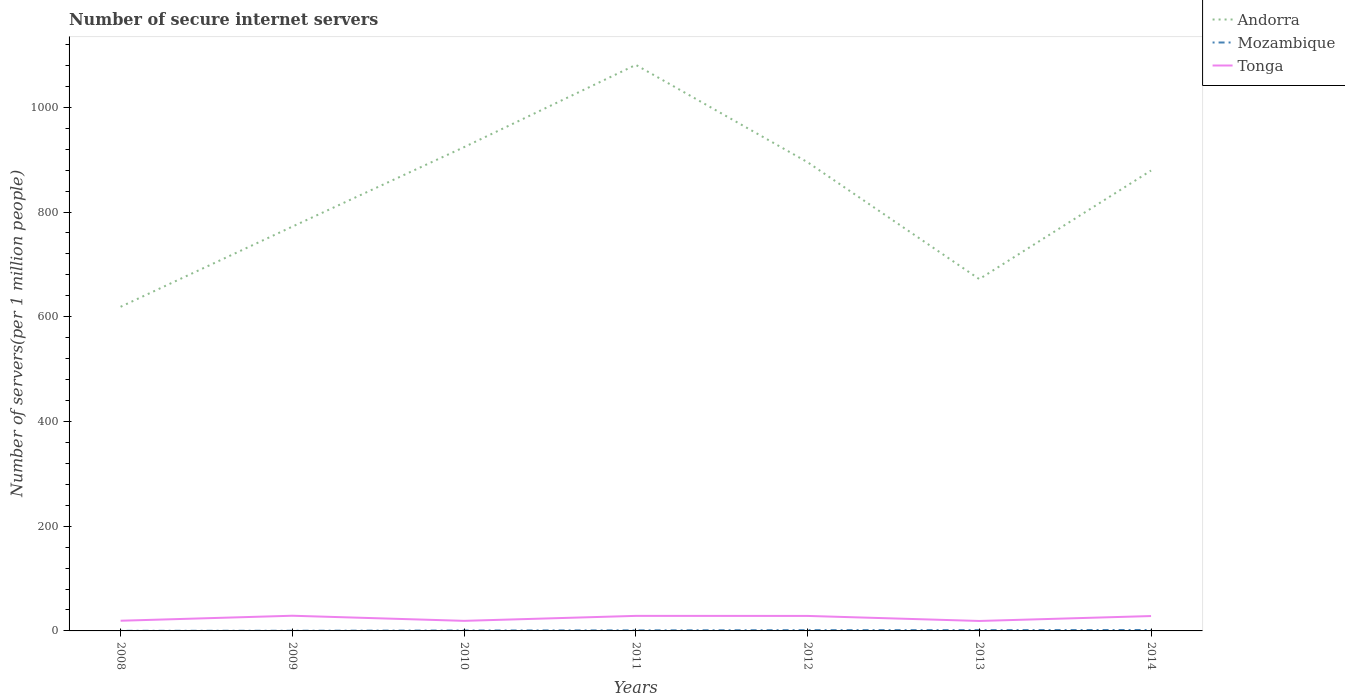Does the line corresponding to Mozambique intersect with the line corresponding to Tonga?
Keep it short and to the point. No. Is the number of lines equal to the number of legend labels?
Ensure brevity in your answer.  Yes. Across all years, what is the maximum number of secure internet servers in Andorra?
Provide a succinct answer. 619.04. In which year was the number of secure internet servers in Mozambique maximum?
Your response must be concise. 2008. What is the total number of secure internet servers in Andorra in the graph?
Offer a very short reply. 409.15. What is the difference between the highest and the second highest number of secure internet servers in Tonga?
Provide a succinct answer. 9.99. What is the difference between the highest and the lowest number of secure internet servers in Tonga?
Your answer should be compact. 4. How many lines are there?
Provide a succinct answer. 3. How many years are there in the graph?
Offer a very short reply. 7. What is the difference between two consecutive major ticks on the Y-axis?
Offer a terse response. 200. Are the values on the major ticks of Y-axis written in scientific E-notation?
Your answer should be very brief. No. Does the graph contain any zero values?
Keep it short and to the point. No. Where does the legend appear in the graph?
Provide a short and direct response. Top right. How are the legend labels stacked?
Your response must be concise. Vertical. What is the title of the graph?
Give a very brief answer. Number of secure internet servers. Does "Botswana" appear as one of the legend labels in the graph?
Your response must be concise. No. What is the label or title of the X-axis?
Provide a succinct answer. Years. What is the label or title of the Y-axis?
Make the answer very short. Number of servers(per 1 million people). What is the Number of servers(per 1 million people) in Andorra in 2008?
Provide a succinct answer. 619.04. What is the Number of servers(per 1 million people) of Mozambique in 2008?
Your answer should be very brief. 0.22. What is the Number of servers(per 1 million people) in Tonga in 2008?
Offer a very short reply. 19.45. What is the Number of servers(per 1 million people) of Andorra in 2009?
Your response must be concise. 772.16. What is the Number of servers(per 1 million people) of Mozambique in 2009?
Offer a very short reply. 0.34. What is the Number of servers(per 1 million people) in Tonga in 2009?
Offer a very short reply. 29.01. What is the Number of servers(per 1 million people) in Andorra in 2010?
Your response must be concise. 923.96. What is the Number of servers(per 1 million people) of Mozambique in 2010?
Give a very brief answer. 0.82. What is the Number of servers(per 1 million people) of Tonga in 2010?
Provide a succinct answer. 19.24. What is the Number of servers(per 1 million people) in Andorra in 2011?
Your answer should be compact. 1081.07. What is the Number of servers(per 1 million people) in Mozambique in 2011?
Ensure brevity in your answer.  1.08. What is the Number of servers(per 1 million people) of Tonga in 2011?
Give a very brief answer. 28.74. What is the Number of servers(per 1 million people) in Andorra in 2012?
Provide a succinct answer. 895.15. What is the Number of servers(per 1 million people) of Mozambique in 2012?
Provide a succinct answer. 1.48. What is the Number of servers(per 1 million people) in Tonga in 2012?
Keep it short and to the point. 28.63. What is the Number of servers(per 1 million people) in Andorra in 2013?
Offer a very short reply. 671.92. What is the Number of servers(per 1 million people) in Mozambique in 2013?
Provide a short and direct response. 1.55. What is the Number of servers(per 1 million people) in Tonga in 2013?
Keep it short and to the point. 19.02. What is the Number of servers(per 1 million people) in Andorra in 2014?
Keep it short and to the point. 879.29. What is the Number of servers(per 1 million people) in Mozambique in 2014?
Make the answer very short. 1.76. What is the Number of servers(per 1 million people) in Tonga in 2014?
Make the answer very short. 28.41. Across all years, what is the maximum Number of servers(per 1 million people) of Andorra?
Provide a short and direct response. 1081.07. Across all years, what is the maximum Number of servers(per 1 million people) of Mozambique?
Give a very brief answer. 1.76. Across all years, what is the maximum Number of servers(per 1 million people) of Tonga?
Make the answer very short. 29.01. Across all years, what is the minimum Number of servers(per 1 million people) of Andorra?
Give a very brief answer. 619.04. Across all years, what is the minimum Number of servers(per 1 million people) in Mozambique?
Offer a very short reply. 0.22. Across all years, what is the minimum Number of servers(per 1 million people) of Tonga?
Give a very brief answer. 19.02. What is the total Number of servers(per 1 million people) in Andorra in the graph?
Make the answer very short. 5842.6. What is the total Number of servers(per 1 million people) of Mozambique in the graph?
Offer a terse response. 7.25. What is the total Number of servers(per 1 million people) in Tonga in the graph?
Your answer should be very brief. 172.51. What is the difference between the Number of servers(per 1 million people) in Andorra in 2008 and that in 2009?
Offer a very short reply. -153.12. What is the difference between the Number of servers(per 1 million people) in Mozambique in 2008 and that in 2009?
Keep it short and to the point. -0.12. What is the difference between the Number of servers(per 1 million people) of Tonga in 2008 and that in 2009?
Your answer should be very brief. -9.56. What is the difference between the Number of servers(per 1 million people) in Andorra in 2008 and that in 2010?
Provide a short and direct response. -304.92. What is the difference between the Number of servers(per 1 million people) of Mozambique in 2008 and that in 2010?
Offer a terse response. -0.6. What is the difference between the Number of servers(per 1 million people) in Tonga in 2008 and that in 2010?
Give a very brief answer. 0.21. What is the difference between the Number of servers(per 1 million people) in Andorra in 2008 and that in 2011?
Your answer should be compact. -462.02. What is the difference between the Number of servers(per 1 million people) in Mozambique in 2008 and that in 2011?
Offer a terse response. -0.86. What is the difference between the Number of servers(per 1 million people) in Tonga in 2008 and that in 2011?
Offer a very short reply. -9.29. What is the difference between the Number of servers(per 1 million people) in Andorra in 2008 and that in 2012?
Make the answer very short. -276.11. What is the difference between the Number of servers(per 1 million people) in Mozambique in 2008 and that in 2012?
Give a very brief answer. -1.26. What is the difference between the Number of servers(per 1 million people) of Tonga in 2008 and that in 2012?
Ensure brevity in your answer.  -9.18. What is the difference between the Number of servers(per 1 million people) of Andorra in 2008 and that in 2013?
Your answer should be very brief. -52.88. What is the difference between the Number of servers(per 1 million people) of Mozambique in 2008 and that in 2013?
Offer a very short reply. -1.33. What is the difference between the Number of servers(per 1 million people) of Tonga in 2008 and that in 2013?
Your answer should be compact. 0.43. What is the difference between the Number of servers(per 1 million people) of Andorra in 2008 and that in 2014?
Keep it short and to the point. -260.25. What is the difference between the Number of servers(per 1 million people) in Mozambique in 2008 and that in 2014?
Keep it short and to the point. -1.55. What is the difference between the Number of servers(per 1 million people) of Tonga in 2008 and that in 2014?
Provide a short and direct response. -8.96. What is the difference between the Number of servers(per 1 million people) in Andorra in 2009 and that in 2010?
Offer a very short reply. -151.8. What is the difference between the Number of servers(per 1 million people) in Mozambique in 2009 and that in 2010?
Give a very brief answer. -0.48. What is the difference between the Number of servers(per 1 million people) of Tonga in 2009 and that in 2010?
Give a very brief answer. 9.77. What is the difference between the Number of servers(per 1 million people) of Andorra in 2009 and that in 2011?
Your answer should be very brief. -308.9. What is the difference between the Number of servers(per 1 million people) of Mozambique in 2009 and that in 2011?
Offer a terse response. -0.74. What is the difference between the Number of servers(per 1 million people) in Tonga in 2009 and that in 2011?
Make the answer very short. 0.27. What is the difference between the Number of servers(per 1 million people) in Andorra in 2009 and that in 2012?
Ensure brevity in your answer.  -122.99. What is the difference between the Number of servers(per 1 million people) in Mozambique in 2009 and that in 2012?
Give a very brief answer. -1.14. What is the difference between the Number of servers(per 1 million people) of Tonga in 2009 and that in 2012?
Ensure brevity in your answer.  0.37. What is the difference between the Number of servers(per 1 million people) of Andorra in 2009 and that in 2013?
Give a very brief answer. 100.25. What is the difference between the Number of servers(per 1 million people) of Mozambique in 2009 and that in 2013?
Your response must be concise. -1.21. What is the difference between the Number of servers(per 1 million people) in Tonga in 2009 and that in 2013?
Provide a succinct answer. 9.99. What is the difference between the Number of servers(per 1 million people) of Andorra in 2009 and that in 2014?
Your response must be concise. -107.13. What is the difference between the Number of servers(per 1 million people) of Mozambique in 2009 and that in 2014?
Offer a terse response. -1.43. What is the difference between the Number of servers(per 1 million people) of Tonga in 2009 and that in 2014?
Provide a succinct answer. 0.6. What is the difference between the Number of servers(per 1 million people) in Andorra in 2010 and that in 2011?
Your answer should be very brief. -157.11. What is the difference between the Number of servers(per 1 million people) in Mozambique in 2010 and that in 2011?
Keep it short and to the point. -0.26. What is the difference between the Number of servers(per 1 million people) of Tonga in 2010 and that in 2011?
Your answer should be very brief. -9.5. What is the difference between the Number of servers(per 1 million people) in Andorra in 2010 and that in 2012?
Provide a short and direct response. 28.81. What is the difference between the Number of servers(per 1 million people) in Mozambique in 2010 and that in 2012?
Offer a terse response. -0.65. What is the difference between the Number of servers(per 1 million people) of Tonga in 2010 and that in 2012?
Keep it short and to the point. -9.39. What is the difference between the Number of servers(per 1 million people) of Andorra in 2010 and that in 2013?
Give a very brief answer. 252.04. What is the difference between the Number of servers(per 1 million people) in Mozambique in 2010 and that in 2013?
Keep it short and to the point. -0.73. What is the difference between the Number of servers(per 1 million people) in Tonga in 2010 and that in 2013?
Make the answer very short. 0.22. What is the difference between the Number of servers(per 1 million people) in Andorra in 2010 and that in 2014?
Your answer should be very brief. 44.67. What is the difference between the Number of servers(per 1 million people) in Mozambique in 2010 and that in 2014?
Offer a very short reply. -0.94. What is the difference between the Number of servers(per 1 million people) in Tonga in 2010 and that in 2014?
Your response must be concise. -9.17. What is the difference between the Number of servers(per 1 million people) of Andorra in 2011 and that in 2012?
Your answer should be compact. 185.91. What is the difference between the Number of servers(per 1 million people) of Mozambique in 2011 and that in 2012?
Give a very brief answer. -0.4. What is the difference between the Number of servers(per 1 million people) of Tonga in 2011 and that in 2012?
Give a very brief answer. 0.1. What is the difference between the Number of servers(per 1 million people) of Andorra in 2011 and that in 2013?
Offer a very short reply. 409.15. What is the difference between the Number of servers(per 1 million people) of Mozambique in 2011 and that in 2013?
Your answer should be very brief. -0.47. What is the difference between the Number of servers(per 1 million people) in Tonga in 2011 and that in 2013?
Ensure brevity in your answer.  9.72. What is the difference between the Number of servers(per 1 million people) in Andorra in 2011 and that in 2014?
Give a very brief answer. 201.78. What is the difference between the Number of servers(per 1 million people) in Mozambique in 2011 and that in 2014?
Ensure brevity in your answer.  -0.68. What is the difference between the Number of servers(per 1 million people) of Tonga in 2011 and that in 2014?
Keep it short and to the point. 0.33. What is the difference between the Number of servers(per 1 million people) in Andorra in 2012 and that in 2013?
Offer a terse response. 223.23. What is the difference between the Number of servers(per 1 million people) of Mozambique in 2012 and that in 2013?
Ensure brevity in your answer.  -0.07. What is the difference between the Number of servers(per 1 million people) of Tonga in 2012 and that in 2013?
Ensure brevity in your answer.  9.61. What is the difference between the Number of servers(per 1 million people) in Andorra in 2012 and that in 2014?
Keep it short and to the point. 15.86. What is the difference between the Number of servers(per 1 million people) in Mozambique in 2012 and that in 2014?
Your response must be concise. -0.29. What is the difference between the Number of servers(per 1 million people) in Tonga in 2012 and that in 2014?
Offer a terse response. 0.22. What is the difference between the Number of servers(per 1 million people) of Andorra in 2013 and that in 2014?
Keep it short and to the point. -207.37. What is the difference between the Number of servers(per 1 million people) of Mozambique in 2013 and that in 2014?
Ensure brevity in your answer.  -0.21. What is the difference between the Number of servers(per 1 million people) in Tonga in 2013 and that in 2014?
Offer a terse response. -9.39. What is the difference between the Number of servers(per 1 million people) of Andorra in 2008 and the Number of servers(per 1 million people) of Mozambique in 2009?
Provide a succinct answer. 618.7. What is the difference between the Number of servers(per 1 million people) in Andorra in 2008 and the Number of servers(per 1 million people) in Tonga in 2009?
Your response must be concise. 590.03. What is the difference between the Number of servers(per 1 million people) in Mozambique in 2008 and the Number of servers(per 1 million people) in Tonga in 2009?
Provide a succinct answer. -28.79. What is the difference between the Number of servers(per 1 million people) in Andorra in 2008 and the Number of servers(per 1 million people) in Mozambique in 2010?
Keep it short and to the point. 618.22. What is the difference between the Number of servers(per 1 million people) of Andorra in 2008 and the Number of servers(per 1 million people) of Tonga in 2010?
Offer a terse response. 599.8. What is the difference between the Number of servers(per 1 million people) of Mozambique in 2008 and the Number of servers(per 1 million people) of Tonga in 2010?
Keep it short and to the point. -19.02. What is the difference between the Number of servers(per 1 million people) of Andorra in 2008 and the Number of servers(per 1 million people) of Mozambique in 2011?
Provide a succinct answer. 617.96. What is the difference between the Number of servers(per 1 million people) in Andorra in 2008 and the Number of servers(per 1 million people) in Tonga in 2011?
Offer a very short reply. 590.31. What is the difference between the Number of servers(per 1 million people) of Mozambique in 2008 and the Number of servers(per 1 million people) of Tonga in 2011?
Your answer should be very brief. -28.52. What is the difference between the Number of servers(per 1 million people) of Andorra in 2008 and the Number of servers(per 1 million people) of Mozambique in 2012?
Your response must be concise. 617.57. What is the difference between the Number of servers(per 1 million people) in Andorra in 2008 and the Number of servers(per 1 million people) in Tonga in 2012?
Provide a short and direct response. 590.41. What is the difference between the Number of servers(per 1 million people) in Mozambique in 2008 and the Number of servers(per 1 million people) in Tonga in 2012?
Ensure brevity in your answer.  -28.42. What is the difference between the Number of servers(per 1 million people) of Andorra in 2008 and the Number of servers(per 1 million people) of Mozambique in 2013?
Make the answer very short. 617.49. What is the difference between the Number of servers(per 1 million people) in Andorra in 2008 and the Number of servers(per 1 million people) in Tonga in 2013?
Ensure brevity in your answer.  600.02. What is the difference between the Number of servers(per 1 million people) in Mozambique in 2008 and the Number of servers(per 1 million people) in Tonga in 2013?
Provide a short and direct response. -18.8. What is the difference between the Number of servers(per 1 million people) in Andorra in 2008 and the Number of servers(per 1 million people) in Mozambique in 2014?
Your answer should be very brief. 617.28. What is the difference between the Number of servers(per 1 million people) of Andorra in 2008 and the Number of servers(per 1 million people) of Tonga in 2014?
Ensure brevity in your answer.  590.63. What is the difference between the Number of servers(per 1 million people) in Mozambique in 2008 and the Number of servers(per 1 million people) in Tonga in 2014?
Ensure brevity in your answer.  -28.2. What is the difference between the Number of servers(per 1 million people) in Andorra in 2009 and the Number of servers(per 1 million people) in Mozambique in 2010?
Keep it short and to the point. 771.34. What is the difference between the Number of servers(per 1 million people) of Andorra in 2009 and the Number of servers(per 1 million people) of Tonga in 2010?
Keep it short and to the point. 752.92. What is the difference between the Number of servers(per 1 million people) of Mozambique in 2009 and the Number of servers(per 1 million people) of Tonga in 2010?
Provide a short and direct response. -18.9. What is the difference between the Number of servers(per 1 million people) of Andorra in 2009 and the Number of servers(per 1 million people) of Mozambique in 2011?
Ensure brevity in your answer.  771.09. What is the difference between the Number of servers(per 1 million people) of Andorra in 2009 and the Number of servers(per 1 million people) of Tonga in 2011?
Your answer should be compact. 743.43. What is the difference between the Number of servers(per 1 million people) in Mozambique in 2009 and the Number of servers(per 1 million people) in Tonga in 2011?
Keep it short and to the point. -28.4. What is the difference between the Number of servers(per 1 million people) of Andorra in 2009 and the Number of servers(per 1 million people) of Mozambique in 2012?
Give a very brief answer. 770.69. What is the difference between the Number of servers(per 1 million people) of Andorra in 2009 and the Number of servers(per 1 million people) of Tonga in 2012?
Offer a very short reply. 743.53. What is the difference between the Number of servers(per 1 million people) of Mozambique in 2009 and the Number of servers(per 1 million people) of Tonga in 2012?
Your response must be concise. -28.3. What is the difference between the Number of servers(per 1 million people) of Andorra in 2009 and the Number of servers(per 1 million people) of Mozambique in 2013?
Keep it short and to the point. 770.62. What is the difference between the Number of servers(per 1 million people) of Andorra in 2009 and the Number of servers(per 1 million people) of Tonga in 2013?
Your answer should be compact. 753.14. What is the difference between the Number of servers(per 1 million people) in Mozambique in 2009 and the Number of servers(per 1 million people) in Tonga in 2013?
Ensure brevity in your answer.  -18.68. What is the difference between the Number of servers(per 1 million people) in Andorra in 2009 and the Number of servers(per 1 million people) in Mozambique in 2014?
Provide a succinct answer. 770.4. What is the difference between the Number of servers(per 1 million people) in Andorra in 2009 and the Number of servers(per 1 million people) in Tonga in 2014?
Your answer should be very brief. 743.75. What is the difference between the Number of servers(per 1 million people) in Mozambique in 2009 and the Number of servers(per 1 million people) in Tonga in 2014?
Provide a succinct answer. -28.07. What is the difference between the Number of servers(per 1 million people) of Andorra in 2010 and the Number of servers(per 1 million people) of Mozambique in 2011?
Provide a succinct answer. 922.88. What is the difference between the Number of servers(per 1 million people) of Andorra in 2010 and the Number of servers(per 1 million people) of Tonga in 2011?
Your answer should be compact. 895.22. What is the difference between the Number of servers(per 1 million people) of Mozambique in 2010 and the Number of servers(per 1 million people) of Tonga in 2011?
Your answer should be very brief. -27.92. What is the difference between the Number of servers(per 1 million people) of Andorra in 2010 and the Number of servers(per 1 million people) of Mozambique in 2012?
Make the answer very short. 922.49. What is the difference between the Number of servers(per 1 million people) in Andorra in 2010 and the Number of servers(per 1 million people) in Tonga in 2012?
Provide a succinct answer. 895.33. What is the difference between the Number of servers(per 1 million people) of Mozambique in 2010 and the Number of servers(per 1 million people) of Tonga in 2012?
Offer a very short reply. -27.81. What is the difference between the Number of servers(per 1 million people) of Andorra in 2010 and the Number of servers(per 1 million people) of Mozambique in 2013?
Provide a short and direct response. 922.41. What is the difference between the Number of servers(per 1 million people) of Andorra in 2010 and the Number of servers(per 1 million people) of Tonga in 2013?
Make the answer very short. 904.94. What is the difference between the Number of servers(per 1 million people) of Mozambique in 2010 and the Number of servers(per 1 million people) of Tonga in 2013?
Provide a succinct answer. -18.2. What is the difference between the Number of servers(per 1 million people) of Andorra in 2010 and the Number of servers(per 1 million people) of Mozambique in 2014?
Ensure brevity in your answer.  922.2. What is the difference between the Number of servers(per 1 million people) in Andorra in 2010 and the Number of servers(per 1 million people) in Tonga in 2014?
Your answer should be compact. 895.55. What is the difference between the Number of servers(per 1 million people) in Mozambique in 2010 and the Number of servers(per 1 million people) in Tonga in 2014?
Provide a succinct answer. -27.59. What is the difference between the Number of servers(per 1 million people) of Andorra in 2011 and the Number of servers(per 1 million people) of Mozambique in 2012?
Your answer should be compact. 1079.59. What is the difference between the Number of servers(per 1 million people) of Andorra in 2011 and the Number of servers(per 1 million people) of Tonga in 2012?
Provide a short and direct response. 1052.43. What is the difference between the Number of servers(per 1 million people) of Mozambique in 2011 and the Number of servers(per 1 million people) of Tonga in 2012?
Your answer should be very brief. -27.56. What is the difference between the Number of servers(per 1 million people) of Andorra in 2011 and the Number of servers(per 1 million people) of Mozambique in 2013?
Ensure brevity in your answer.  1079.52. What is the difference between the Number of servers(per 1 million people) of Andorra in 2011 and the Number of servers(per 1 million people) of Tonga in 2013?
Make the answer very short. 1062.05. What is the difference between the Number of servers(per 1 million people) in Mozambique in 2011 and the Number of servers(per 1 million people) in Tonga in 2013?
Keep it short and to the point. -17.94. What is the difference between the Number of servers(per 1 million people) in Andorra in 2011 and the Number of servers(per 1 million people) in Mozambique in 2014?
Keep it short and to the point. 1079.3. What is the difference between the Number of servers(per 1 million people) of Andorra in 2011 and the Number of servers(per 1 million people) of Tonga in 2014?
Ensure brevity in your answer.  1052.66. What is the difference between the Number of servers(per 1 million people) in Mozambique in 2011 and the Number of servers(per 1 million people) in Tonga in 2014?
Keep it short and to the point. -27.33. What is the difference between the Number of servers(per 1 million people) in Andorra in 2012 and the Number of servers(per 1 million people) in Mozambique in 2013?
Give a very brief answer. 893.6. What is the difference between the Number of servers(per 1 million people) in Andorra in 2012 and the Number of servers(per 1 million people) in Tonga in 2013?
Offer a very short reply. 876.13. What is the difference between the Number of servers(per 1 million people) in Mozambique in 2012 and the Number of servers(per 1 million people) in Tonga in 2013?
Offer a very short reply. -17.55. What is the difference between the Number of servers(per 1 million people) in Andorra in 2012 and the Number of servers(per 1 million people) in Mozambique in 2014?
Offer a very short reply. 893.39. What is the difference between the Number of servers(per 1 million people) of Andorra in 2012 and the Number of servers(per 1 million people) of Tonga in 2014?
Offer a terse response. 866.74. What is the difference between the Number of servers(per 1 million people) in Mozambique in 2012 and the Number of servers(per 1 million people) in Tonga in 2014?
Offer a terse response. -26.94. What is the difference between the Number of servers(per 1 million people) in Andorra in 2013 and the Number of servers(per 1 million people) in Mozambique in 2014?
Provide a short and direct response. 670.16. What is the difference between the Number of servers(per 1 million people) of Andorra in 2013 and the Number of servers(per 1 million people) of Tonga in 2014?
Make the answer very short. 643.51. What is the difference between the Number of servers(per 1 million people) in Mozambique in 2013 and the Number of servers(per 1 million people) in Tonga in 2014?
Your answer should be very brief. -26.86. What is the average Number of servers(per 1 million people) in Andorra per year?
Give a very brief answer. 834.66. What is the average Number of servers(per 1 million people) in Mozambique per year?
Your response must be concise. 1.04. What is the average Number of servers(per 1 million people) in Tonga per year?
Make the answer very short. 24.64. In the year 2008, what is the difference between the Number of servers(per 1 million people) in Andorra and Number of servers(per 1 million people) in Mozambique?
Provide a short and direct response. 618.83. In the year 2008, what is the difference between the Number of servers(per 1 million people) of Andorra and Number of servers(per 1 million people) of Tonga?
Ensure brevity in your answer.  599.59. In the year 2008, what is the difference between the Number of servers(per 1 million people) of Mozambique and Number of servers(per 1 million people) of Tonga?
Give a very brief answer. -19.23. In the year 2009, what is the difference between the Number of servers(per 1 million people) of Andorra and Number of servers(per 1 million people) of Mozambique?
Give a very brief answer. 771.83. In the year 2009, what is the difference between the Number of servers(per 1 million people) of Andorra and Number of servers(per 1 million people) of Tonga?
Provide a short and direct response. 743.16. In the year 2009, what is the difference between the Number of servers(per 1 million people) of Mozambique and Number of servers(per 1 million people) of Tonga?
Make the answer very short. -28.67. In the year 2010, what is the difference between the Number of servers(per 1 million people) of Andorra and Number of servers(per 1 million people) of Mozambique?
Give a very brief answer. 923.14. In the year 2010, what is the difference between the Number of servers(per 1 million people) in Andorra and Number of servers(per 1 million people) in Tonga?
Ensure brevity in your answer.  904.72. In the year 2010, what is the difference between the Number of servers(per 1 million people) in Mozambique and Number of servers(per 1 million people) in Tonga?
Offer a very short reply. -18.42. In the year 2011, what is the difference between the Number of servers(per 1 million people) in Andorra and Number of servers(per 1 million people) in Mozambique?
Provide a short and direct response. 1079.99. In the year 2011, what is the difference between the Number of servers(per 1 million people) of Andorra and Number of servers(per 1 million people) of Tonga?
Make the answer very short. 1052.33. In the year 2011, what is the difference between the Number of servers(per 1 million people) of Mozambique and Number of servers(per 1 million people) of Tonga?
Your answer should be very brief. -27.66. In the year 2012, what is the difference between the Number of servers(per 1 million people) of Andorra and Number of servers(per 1 million people) of Mozambique?
Keep it short and to the point. 893.68. In the year 2012, what is the difference between the Number of servers(per 1 million people) of Andorra and Number of servers(per 1 million people) of Tonga?
Your answer should be compact. 866.52. In the year 2012, what is the difference between the Number of servers(per 1 million people) in Mozambique and Number of servers(per 1 million people) in Tonga?
Your answer should be compact. -27.16. In the year 2013, what is the difference between the Number of servers(per 1 million people) of Andorra and Number of servers(per 1 million people) of Mozambique?
Your response must be concise. 670.37. In the year 2013, what is the difference between the Number of servers(per 1 million people) in Andorra and Number of servers(per 1 million people) in Tonga?
Provide a short and direct response. 652.9. In the year 2013, what is the difference between the Number of servers(per 1 million people) in Mozambique and Number of servers(per 1 million people) in Tonga?
Make the answer very short. -17.47. In the year 2014, what is the difference between the Number of servers(per 1 million people) of Andorra and Number of servers(per 1 million people) of Mozambique?
Make the answer very short. 877.53. In the year 2014, what is the difference between the Number of servers(per 1 million people) of Andorra and Number of servers(per 1 million people) of Tonga?
Your answer should be compact. 850.88. In the year 2014, what is the difference between the Number of servers(per 1 million people) in Mozambique and Number of servers(per 1 million people) in Tonga?
Provide a succinct answer. -26.65. What is the ratio of the Number of servers(per 1 million people) in Andorra in 2008 to that in 2009?
Offer a terse response. 0.8. What is the ratio of the Number of servers(per 1 million people) in Mozambique in 2008 to that in 2009?
Offer a terse response. 0.64. What is the ratio of the Number of servers(per 1 million people) of Tonga in 2008 to that in 2009?
Give a very brief answer. 0.67. What is the ratio of the Number of servers(per 1 million people) in Andorra in 2008 to that in 2010?
Your response must be concise. 0.67. What is the ratio of the Number of servers(per 1 million people) of Mozambique in 2008 to that in 2010?
Your answer should be very brief. 0.26. What is the ratio of the Number of servers(per 1 million people) of Tonga in 2008 to that in 2010?
Give a very brief answer. 1.01. What is the ratio of the Number of servers(per 1 million people) of Andorra in 2008 to that in 2011?
Make the answer very short. 0.57. What is the ratio of the Number of servers(per 1 million people) in Mozambique in 2008 to that in 2011?
Provide a short and direct response. 0.2. What is the ratio of the Number of servers(per 1 million people) in Tonga in 2008 to that in 2011?
Make the answer very short. 0.68. What is the ratio of the Number of servers(per 1 million people) in Andorra in 2008 to that in 2012?
Ensure brevity in your answer.  0.69. What is the ratio of the Number of servers(per 1 million people) in Mozambique in 2008 to that in 2012?
Your response must be concise. 0.15. What is the ratio of the Number of servers(per 1 million people) in Tonga in 2008 to that in 2012?
Offer a very short reply. 0.68. What is the ratio of the Number of servers(per 1 million people) in Andorra in 2008 to that in 2013?
Offer a terse response. 0.92. What is the ratio of the Number of servers(per 1 million people) of Mozambique in 2008 to that in 2013?
Give a very brief answer. 0.14. What is the ratio of the Number of servers(per 1 million people) of Tonga in 2008 to that in 2013?
Provide a succinct answer. 1.02. What is the ratio of the Number of servers(per 1 million people) in Andorra in 2008 to that in 2014?
Offer a terse response. 0.7. What is the ratio of the Number of servers(per 1 million people) of Mozambique in 2008 to that in 2014?
Your answer should be compact. 0.12. What is the ratio of the Number of servers(per 1 million people) in Tonga in 2008 to that in 2014?
Offer a very short reply. 0.68. What is the ratio of the Number of servers(per 1 million people) in Andorra in 2009 to that in 2010?
Provide a short and direct response. 0.84. What is the ratio of the Number of servers(per 1 million people) in Mozambique in 2009 to that in 2010?
Give a very brief answer. 0.41. What is the ratio of the Number of servers(per 1 million people) of Tonga in 2009 to that in 2010?
Keep it short and to the point. 1.51. What is the ratio of the Number of servers(per 1 million people) in Andorra in 2009 to that in 2011?
Your answer should be compact. 0.71. What is the ratio of the Number of servers(per 1 million people) in Mozambique in 2009 to that in 2011?
Offer a terse response. 0.31. What is the ratio of the Number of servers(per 1 million people) of Tonga in 2009 to that in 2011?
Make the answer very short. 1.01. What is the ratio of the Number of servers(per 1 million people) of Andorra in 2009 to that in 2012?
Ensure brevity in your answer.  0.86. What is the ratio of the Number of servers(per 1 million people) of Mozambique in 2009 to that in 2012?
Give a very brief answer. 0.23. What is the ratio of the Number of servers(per 1 million people) in Tonga in 2009 to that in 2012?
Provide a succinct answer. 1.01. What is the ratio of the Number of servers(per 1 million people) of Andorra in 2009 to that in 2013?
Provide a short and direct response. 1.15. What is the ratio of the Number of servers(per 1 million people) of Mozambique in 2009 to that in 2013?
Offer a terse response. 0.22. What is the ratio of the Number of servers(per 1 million people) of Tonga in 2009 to that in 2013?
Your answer should be very brief. 1.52. What is the ratio of the Number of servers(per 1 million people) of Andorra in 2009 to that in 2014?
Keep it short and to the point. 0.88. What is the ratio of the Number of servers(per 1 million people) of Mozambique in 2009 to that in 2014?
Give a very brief answer. 0.19. What is the ratio of the Number of servers(per 1 million people) of Tonga in 2009 to that in 2014?
Keep it short and to the point. 1.02. What is the ratio of the Number of servers(per 1 million people) of Andorra in 2010 to that in 2011?
Offer a terse response. 0.85. What is the ratio of the Number of servers(per 1 million people) of Mozambique in 2010 to that in 2011?
Make the answer very short. 0.76. What is the ratio of the Number of servers(per 1 million people) of Tonga in 2010 to that in 2011?
Your response must be concise. 0.67. What is the ratio of the Number of servers(per 1 million people) of Andorra in 2010 to that in 2012?
Give a very brief answer. 1.03. What is the ratio of the Number of servers(per 1 million people) in Mozambique in 2010 to that in 2012?
Give a very brief answer. 0.56. What is the ratio of the Number of servers(per 1 million people) of Tonga in 2010 to that in 2012?
Offer a very short reply. 0.67. What is the ratio of the Number of servers(per 1 million people) of Andorra in 2010 to that in 2013?
Your answer should be compact. 1.38. What is the ratio of the Number of servers(per 1 million people) of Mozambique in 2010 to that in 2013?
Ensure brevity in your answer.  0.53. What is the ratio of the Number of servers(per 1 million people) of Tonga in 2010 to that in 2013?
Provide a short and direct response. 1.01. What is the ratio of the Number of servers(per 1 million people) in Andorra in 2010 to that in 2014?
Provide a short and direct response. 1.05. What is the ratio of the Number of servers(per 1 million people) in Mozambique in 2010 to that in 2014?
Provide a short and direct response. 0.47. What is the ratio of the Number of servers(per 1 million people) in Tonga in 2010 to that in 2014?
Offer a very short reply. 0.68. What is the ratio of the Number of servers(per 1 million people) in Andorra in 2011 to that in 2012?
Your answer should be very brief. 1.21. What is the ratio of the Number of servers(per 1 million people) in Mozambique in 2011 to that in 2012?
Provide a short and direct response. 0.73. What is the ratio of the Number of servers(per 1 million people) of Tonga in 2011 to that in 2012?
Provide a succinct answer. 1. What is the ratio of the Number of servers(per 1 million people) of Andorra in 2011 to that in 2013?
Your response must be concise. 1.61. What is the ratio of the Number of servers(per 1 million people) in Mozambique in 2011 to that in 2013?
Offer a terse response. 0.7. What is the ratio of the Number of servers(per 1 million people) of Tonga in 2011 to that in 2013?
Offer a very short reply. 1.51. What is the ratio of the Number of servers(per 1 million people) in Andorra in 2011 to that in 2014?
Provide a short and direct response. 1.23. What is the ratio of the Number of servers(per 1 million people) of Mozambique in 2011 to that in 2014?
Provide a succinct answer. 0.61. What is the ratio of the Number of servers(per 1 million people) of Tonga in 2011 to that in 2014?
Make the answer very short. 1.01. What is the ratio of the Number of servers(per 1 million people) of Andorra in 2012 to that in 2013?
Your answer should be compact. 1.33. What is the ratio of the Number of servers(per 1 million people) in Mozambique in 2012 to that in 2013?
Your answer should be very brief. 0.95. What is the ratio of the Number of servers(per 1 million people) in Tonga in 2012 to that in 2013?
Offer a terse response. 1.51. What is the ratio of the Number of servers(per 1 million people) in Andorra in 2012 to that in 2014?
Offer a terse response. 1.02. What is the ratio of the Number of servers(per 1 million people) in Mozambique in 2012 to that in 2014?
Provide a short and direct response. 0.84. What is the ratio of the Number of servers(per 1 million people) of Andorra in 2013 to that in 2014?
Provide a succinct answer. 0.76. What is the ratio of the Number of servers(per 1 million people) in Mozambique in 2013 to that in 2014?
Provide a short and direct response. 0.88. What is the ratio of the Number of servers(per 1 million people) of Tonga in 2013 to that in 2014?
Provide a succinct answer. 0.67. What is the difference between the highest and the second highest Number of servers(per 1 million people) in Andorra?
Your answer should be very brief. 157.11. What is the difference between the highest and the second highest Number of servers(per 1 million people) in Mozambique?
Provide a succinct answer. 0.21. What is the difference between the highest and the second highest Number of servers(per 1 million people) in Tonga?
Make the answer very short. 0.27. What is the difference between the highest and the lowest Number of servers(per 1 million people) in Andorra?
Offer a terse response. 462.02. What is the difference between the highest and the lowest Number of servers(per 1 million people) of Mozambique?
Give a very brief answer. 1.55. What is the difference between the highest and the lowest Number of servers(per 1 million people) in Tonga?
Your response must be concise. 9.99. 